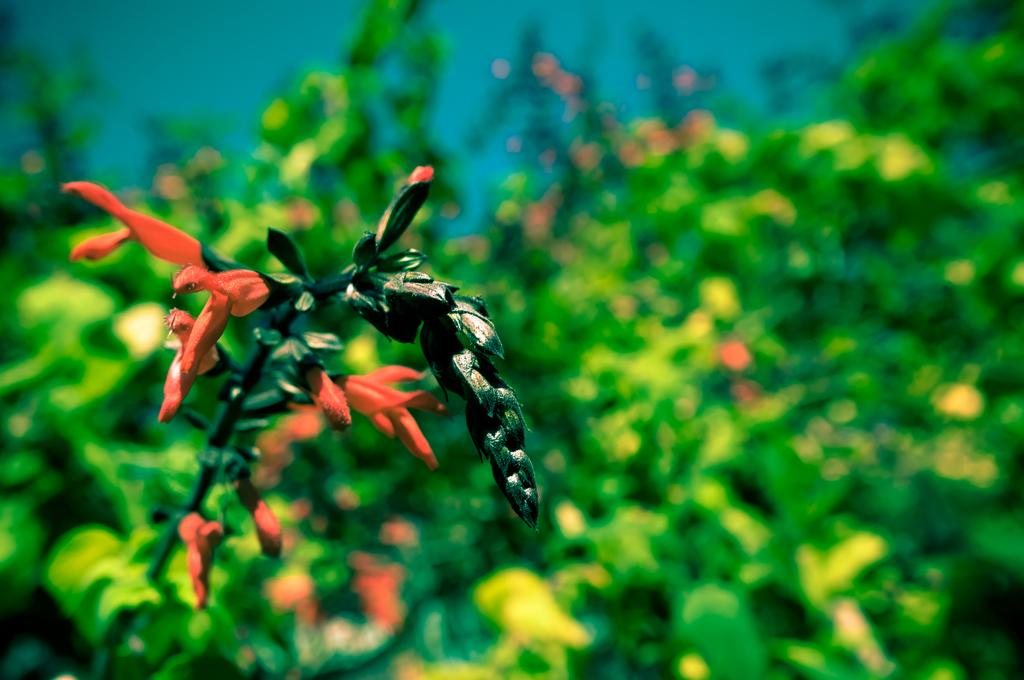What type of flora can be seen in the image? There are flowers in the image. What color are the flowers? The flowers are orange in color. Can you describe any other features of the flowers? There are flower buds visible in the image. What can be seen in the background of the image? There are plants in the background of the image. How is the background of the image depicted? The background is blurred. What type of political system is represented by the flowers in the image? The flowers in the image do not represent any political system; they are simply flowers. 